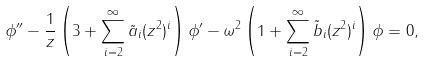<formula> <loc_0><loc_0><loc_500><loc_500>\phi ^ { \prime \prime } - \frac { 1 } { z } \left ( 3 + \sum _ { i = 2 } ^ { \infty } \tilde { a } _ { i } ( z ^ { 2 } ) ^ { i } \right ) \phi ^ { \prime } - \omega ^ { 2 } \left ( 1 + \sum _ { i = 2 } ^ { \infty } \tilde { b } _ { i } ( z ^ { 2 } ) ^ { i } \right ) \phi = 0 ,</formula> 